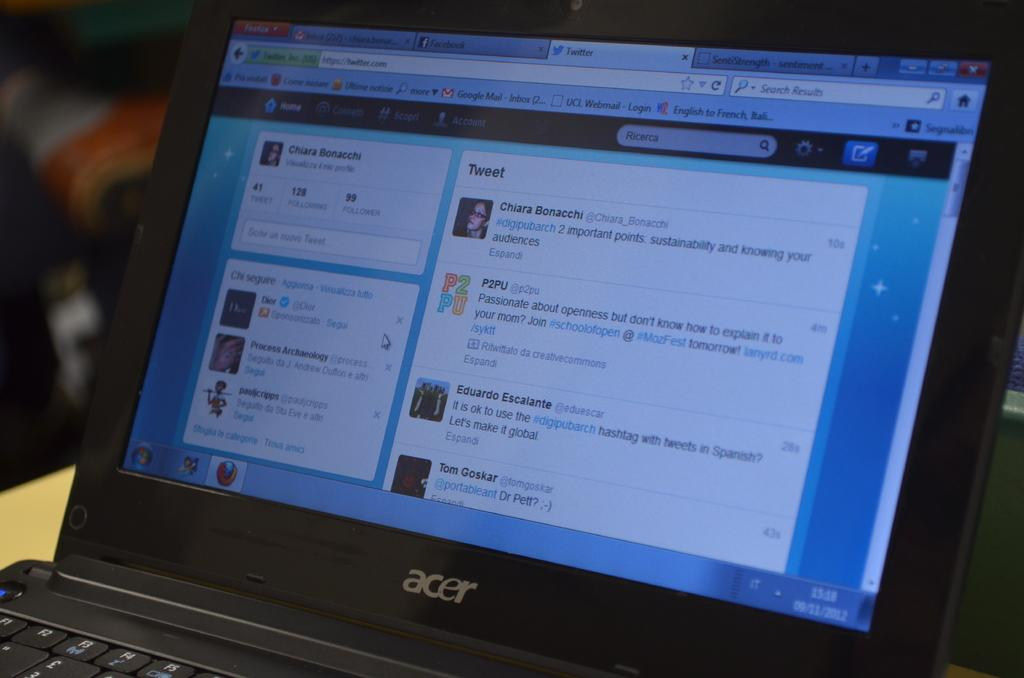<image>
Describe the image concisely. Laptop from the company Acer showing a screen that says "Tweet". 